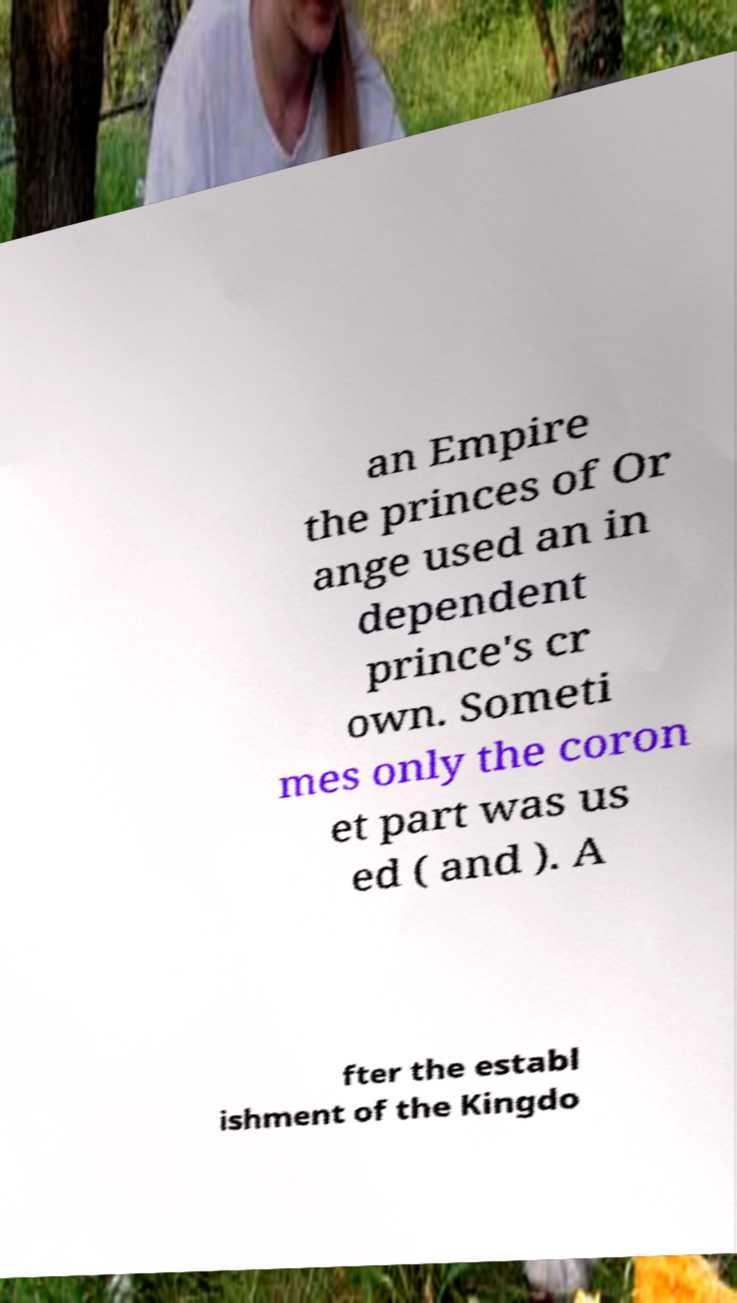Can you accurately transcribe the text from the provided image for me? an Empire the princes of Or ange used an in dependent prince's cr own. Someti mes only the coron et part was us ed ( and ). A fter the establ ishment of the Kingdo 